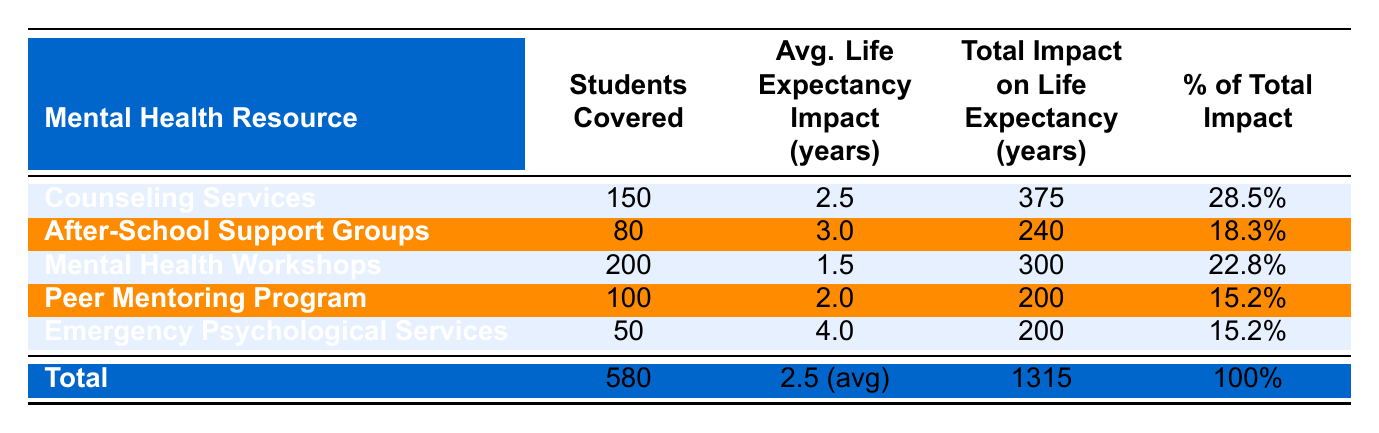What is the total number of students covered by mental health resources? The table lists the total number of students covered by all mental health resources, which is stated directly as 580.
Answer: 580 Which mental health resource had the highest total impact on life expectancy? The total impact on life expectancy for each resource can be found under the "Total Impact on Life Expectancy" column; Counseling Services has the highest total impact of 375.
Answer: Counseling Services What percentage of the total impact on life expectancy is attributed to After-School Support Groups? The percentage attributed to After-School Support Groups is listed directly in the corresponding row, which is 18.3%.
Answer: 18.3% How much total impact on life expectancy does the Peer Mentoring Program contribute? The total impact for the Peer Mentoring Program is found in its respective row under "Total Impact on Life Expectancy," which is 200.
Answer: 200 What is the average life expectancy impact across all resources? The average life expectancy impact is mentioned under the "Avg. Life Expectancy Impact (years)" column; it is an average of 2.5 years for the overall resources covered.
Answer: 2.5 Is it true that Emergency Psychological Services covered more students than the Peer Mentoring Program? Based on the students covered, Emergency Psychological Services covered 50 students while the Peer Mentoring Program covered 100, making the statement false.
Answer: No What is the combined total impact on life expectancy of Counseling Services and Mental Health Workshops? For Counseling Services, the total impact is 375, and for Mental Health Workshops, it is 300. The combined total is therefore 375 + 300 = 675.
Answer: 675 If the average life expectancy impact of Mental Health Workshops is 1.5 years, is it equal to the average impact of the Counseling Services? The average life expectancy impact for Mental Health Workshops is 1.5 years while for Counseling Services, it is 2.5 years, thus they are not equal.
Answer: No What is the total percentage accounted for by Mental Health Workshops and Peer Mentoring Program combined? Mental Health Workshops account for 22.8%, and Peer Mentoring Program accounts for 15.2%. The combined total percentage is 22.8 + 15.2 = 38%.
Answer: 38% 